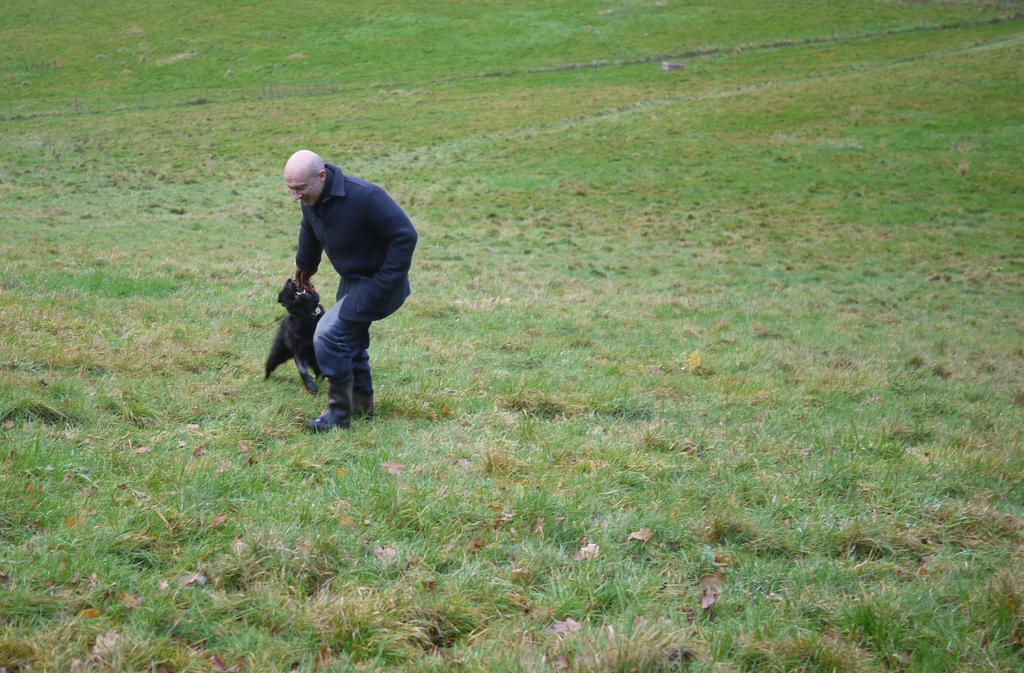What is the man in the image wearing? The man is wearing a jerkin, trousers, and shoes. What type of animal can be seen in the image? There appears to be a dog in the image. What is the color of the dog? The dog is black in color. What type of terrain is visible in the image? There is grass visible in the image. What type of stitch is used to join the fabric of the man's jerkin in the image? There is no information provided about the stitch used to join the fabric of the man's jerkin in the image. 